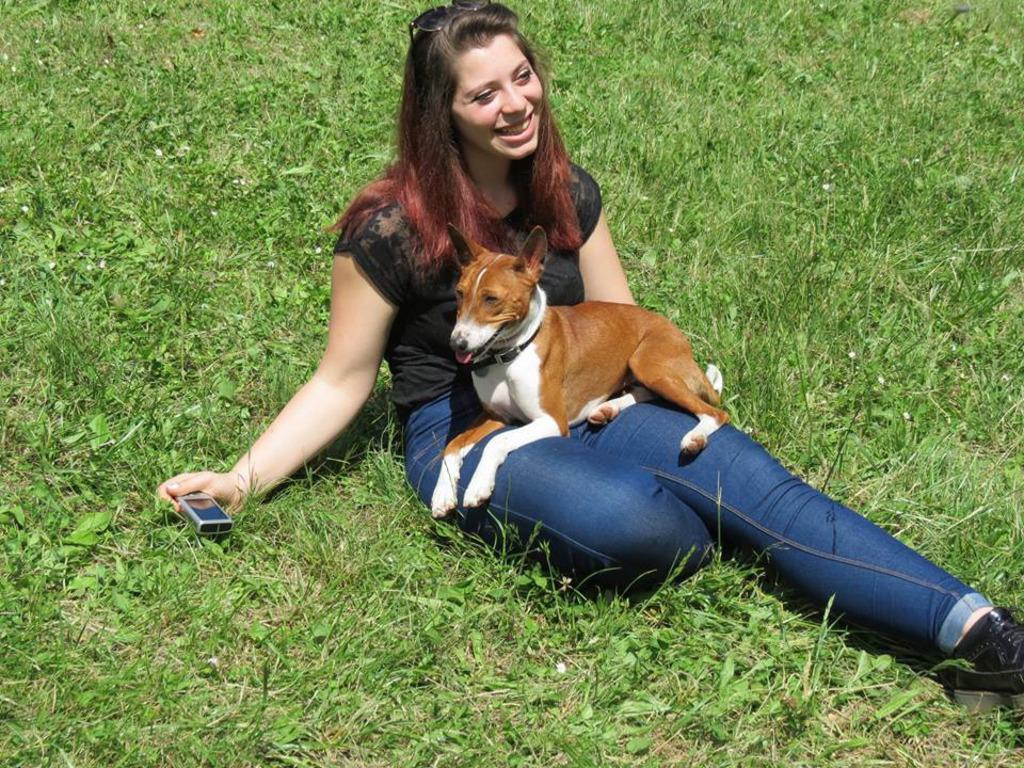Who is the main subject in the image? There is a woman in the image. What is the woman doing in the image? The woman is sitting on the grass and holding a dog on her lap. What else is the woman holding in the image? The woman is holding an electrical device in her hand. What type of amusement park can be seen in the background of the image? There is no amusement park visible in the image; it features a woman sitting on the grass with a dog and an electrical device. 